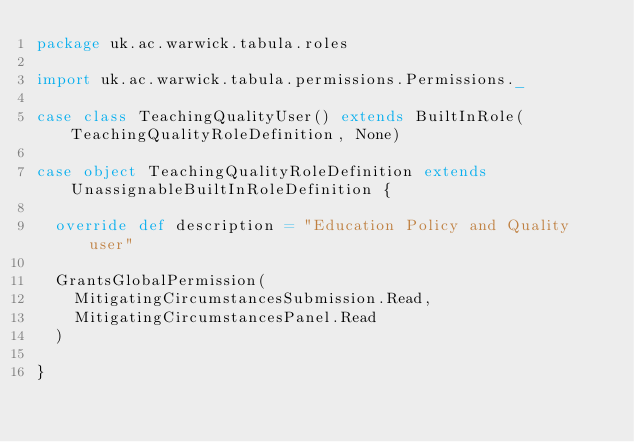Convert code to text. <code><loc_0><loc_0><loc_500><loc_500><_Scala_>package uk.ac.warwick.tabula.roles

import uk.ac.warwick.tabula.permissions.Permissions._

case class TeachingQualityUser() extends BuiltInRole(TeachingQualityRoleDefinition, None)

case object TeachingQualityRoleDefinition extends UnassignableBuiltInRoleDefinition {

  override def description = "Education Policy and Quality user"

  GrantsGlobalPermission(
    MitigatingCircumstancesSubmission.Read,
    MitigatingCircumstancesPanel.Read
  )

}</code> 